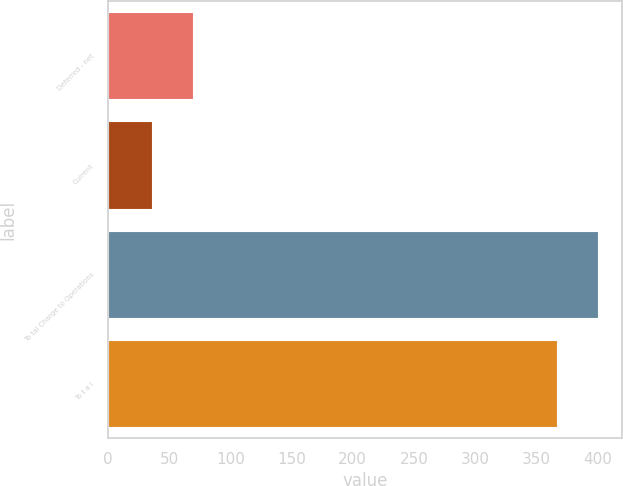Convert chart to OTSL. <chart><loc_0><loc_0><loc_500><loc_500><bar_chart><fcel>Deferred - net<fcel>Current<fcel>To tal Charge to Operations<fcel>To t a l<nl><fcel>69.6<fcel>36<fcel>400.6<fcel>367<nl></chart> 